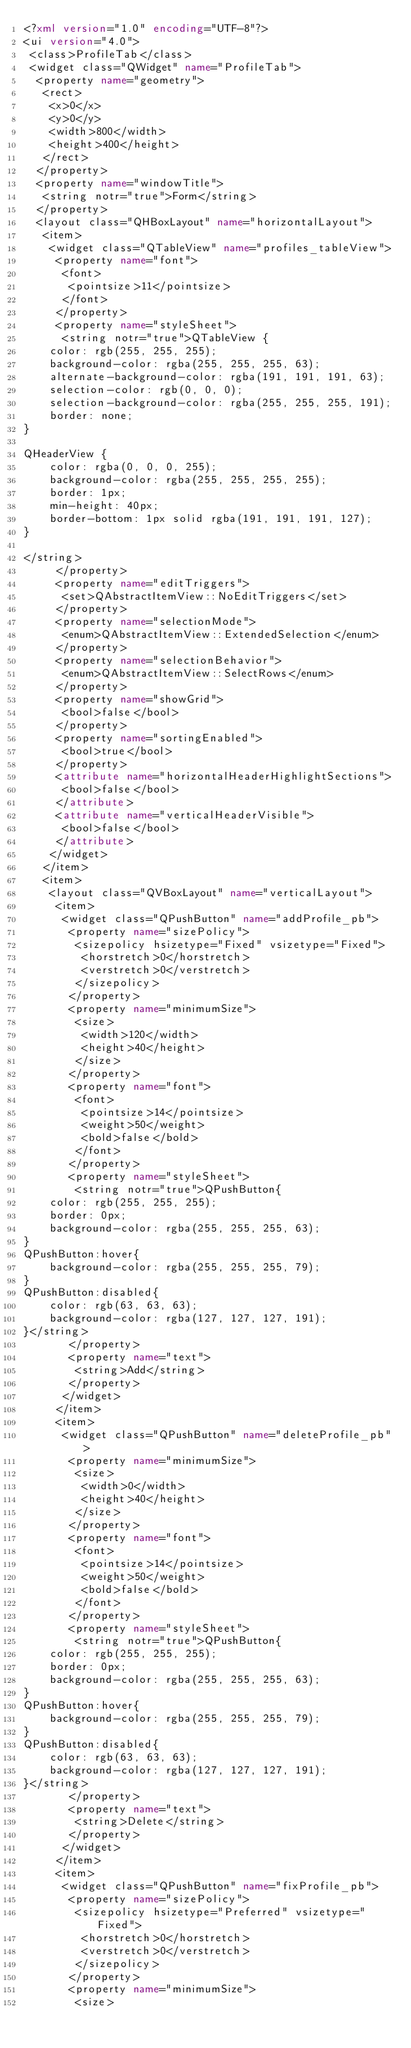<code> <loc_0><loc_0><loc_500><loc_500><_XML_><?xml version="1.0" encoding="UTF-8"?>
<ui version="4.0">
 <class>ProfileTab</class>
 <widget class="QWidget" name="ProfileTab">
  <property name="geometry">
   <rect>
    <x>0</x>
    <y>0</y>
    <width>800</width>
    <height>400</height>
   </rect>
  </property>
  <property name="windowTitle">
   <string notr="true">Form</string>
  </property>
  <layout class="QHBoxLayout" name="horizontalLayout">
   <item>
    <widget class="QTableView" name="profiles_tableView">
     <property name="font">
      <font>
       <pointsize>11</pointsize>
      </font>
     </property>
     <property name="styleSheet">
      <string notr="true">QTableView {
    color: rgb(255, 255, 255);
	background-color: rgba(255, 255, 255, 63);
	alternate-background-color: rgba(191, 191, 191, 63);
    selection-color: rgb(0, 0, 0);
	selection-background-color: rgba(255, 255, 255, 191);
	border: none;
}

QHeaderView {
	color: rgba(0, 0, 0, 255);
	background-color: rgba(255, 255, 255, 255);
    border: 1px;
	min-height: 40px;
	border-bottom: 1px solid rgba(191, 191, 191, 127);
}

</string>
     </property>
     <property name="editTriggers">
      <set>QAbstractItemView::NoEditTriggers</set>
     </property>
     <property name="selectionMode">
      <enum>QAbstractItemView::ExtendedSelection</enum>
     </property>
     <property name="selectionBehavior">
      <enum>QAbstractItemView::SelectRows</enum>
     </property>
     <property name="showGrid">
      <bool>false</bool>
     </property>
     <property name="sortingEnabled">
      <bool>true</bool>
     </property>
     <attribute name="horizontalHeaderHighlightSections">
      <bool>false</bool>
     </attribute>
     <attribute name="verticalHeaderVisible">
      <bool>false</bool>
     </attribute>
    </widget>
   </item>
   <item>
    <layout class="QVBoxLayout" name="verticalLayout">
     <item>
      <widget class="QPushButton" name="addProfile_pb">
       <property name="sizePolicy">
        <sizepolicy hsizetype="Fixed" vsizetype="Fixed">
         <horstretch>0</horstretch>
         <verstretch>0</verstretch>
        </sizepolicy>
       </property>
       <property name="minimumSize">
        <size>
         <width>120</width>
         <height>40</height>
        </size>
       </property>
       <property name="font">
        <font>
         <pointsize>14</pointsize>
         <weight>50</weight>
         <bold>false</bold>
        </font>
       </property>
       <property name="styleSheet">
        <string notr="true">QPushButton{
	color: rgb(255, 255, 255);
	border: 0px;
	background-color: rgba(255, 255, 255, 63);
}
QPushButton:hover{
	background-color: rgba(255, 255, 255, 79);
}
QPushButton:disabled{
	color: rgb(63, 63, 63);
	background-color: rgba(127, 127, 127, 191);
}</string>
       </property>
       <property name="text">
        <string>Add</string>
       </property>
      </widget>
     </item>
     <item>
      <widget class="QPushButton" name="deleteProfile_pb">
       <property name="minimumSize">
        <size>
         <width>0</width>
         <height>40</height>
        </size>
       </property>
       <property name="font">
        <font>
         <pointsize>14</pointsize>
         <weight>50</weight>
         <bold>false</bold>
        </font>
       </property>
       <property name="styleSheet">
        <string notr="true">QPushButton{
	color: rgb(255, 255, 255);
	border: 0px;
	background-color: rgba(255, 255, 255, 63);
}
QPushButton:hover{
	background-color: rgba(255, 255, 255, 79);
}
QPushButton:disabled{
	color: rgb(63, 63, 63);
	background-color: rgba(127, 127, 127, 191);
}</string>
       </property>
       <property name="text">
        <string>Delete</string>
       </property>
      </widget>
     </item>
     <item>
      <widget class="QPushButton" name="fixProfile_pb">
       <property name="sizePolicy">
        <sizepolicy hsizetype="Preferred" vsizetype="Fixed">
         <horstretch>0</horstretch>
         <verstretch>0</verstretch>
        </sizepolicy>
       </property>
       <property name="minimumSize">
        <size></code> 